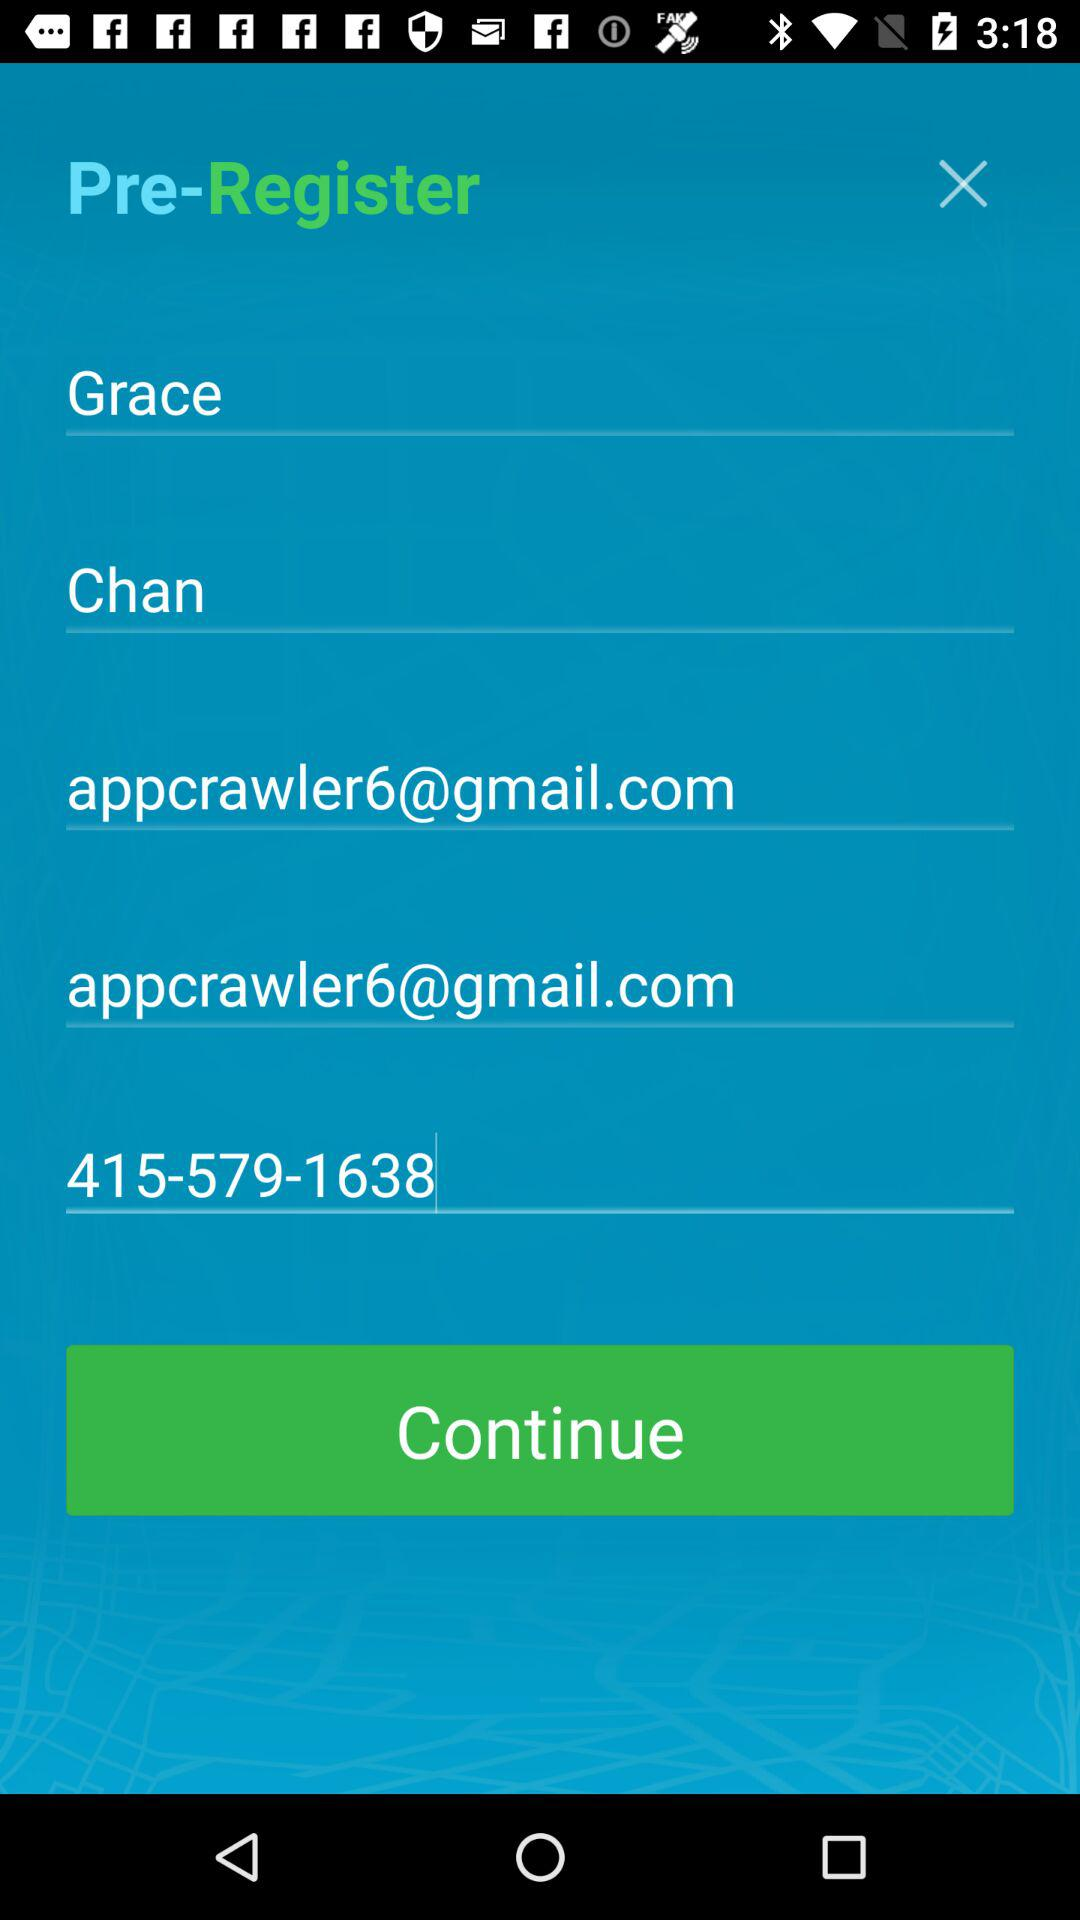What is the contact number of the user? The contact number of the user is 415-579-1638. 